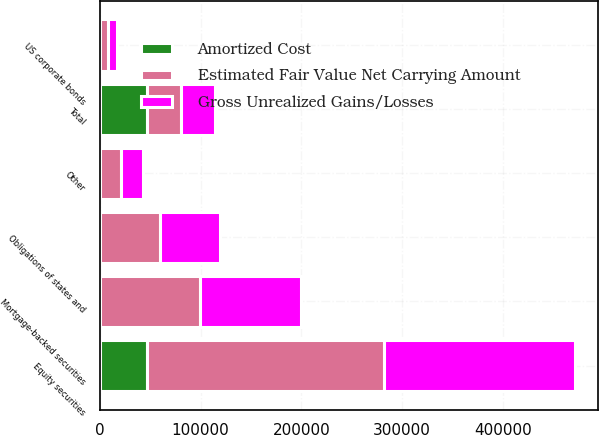Convert chart to OTSL. <chart><loc_0><loc_0><loc_500><loc_500><stacked_bar_chart><ecel><fcel>Mortgage-backed securities<fcel>Obligations of states and<fcel>US corporate bonds<fcel>Equity securities<fcel>Other<fcel>Total<nl><fcel>Gross Unrealized Gains/Losses<fcel>99749<fcel>59497<fcel>8479<fcel>188971<fcel>21333<fcel>33904.5<nl><fcel>Amortized Cost<fcel>68<fcel>158<fcel>219<fcel>46688<fcel>83<fcel>46476<nl><fcel>Estimated Fair Value Net Carrying Amount<fcel>99681<fcel>59655<fcel>8260<fcel>235659<fcel>21250<fcel>33904.5<nl></chart> 